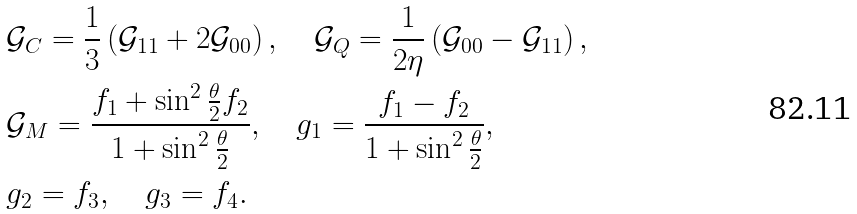<formula> <loc_0><loc_0><loc_500><loc_500>& \mathcal { G } _ { C } = \frac { 1 } { 3 } \left ( \mathcal { G } _ { 1 1 } + 2 \mathcal { G } _ { 0 0 } \right ) , \quad \mathcal { G } _ { Q } = \frac { 1 } { 2 \eta } \left ( \mathcal { G } _ { 0 0 } - \mathcal { G } _ { 1 1 } \right ) , \\ & \mathcal { G } _ { M } = \frac { f _ { 1 } + \sin ^ { 2 } \frac { \theta } 2 f _ { 2 } } { 1 + \sin ^ { 2 } \frac { \theta } 2 } , \quad g _ { 1 } = \frac { f _ { 1 } - f _ { 2 } } { 1 + \sin ^ { 2 } \frac { \theta } 2 } , \\ & g _ { 2 } = f _ { 3 } , \quad g _ { 3 } = f _ { 4 } .</formula> 